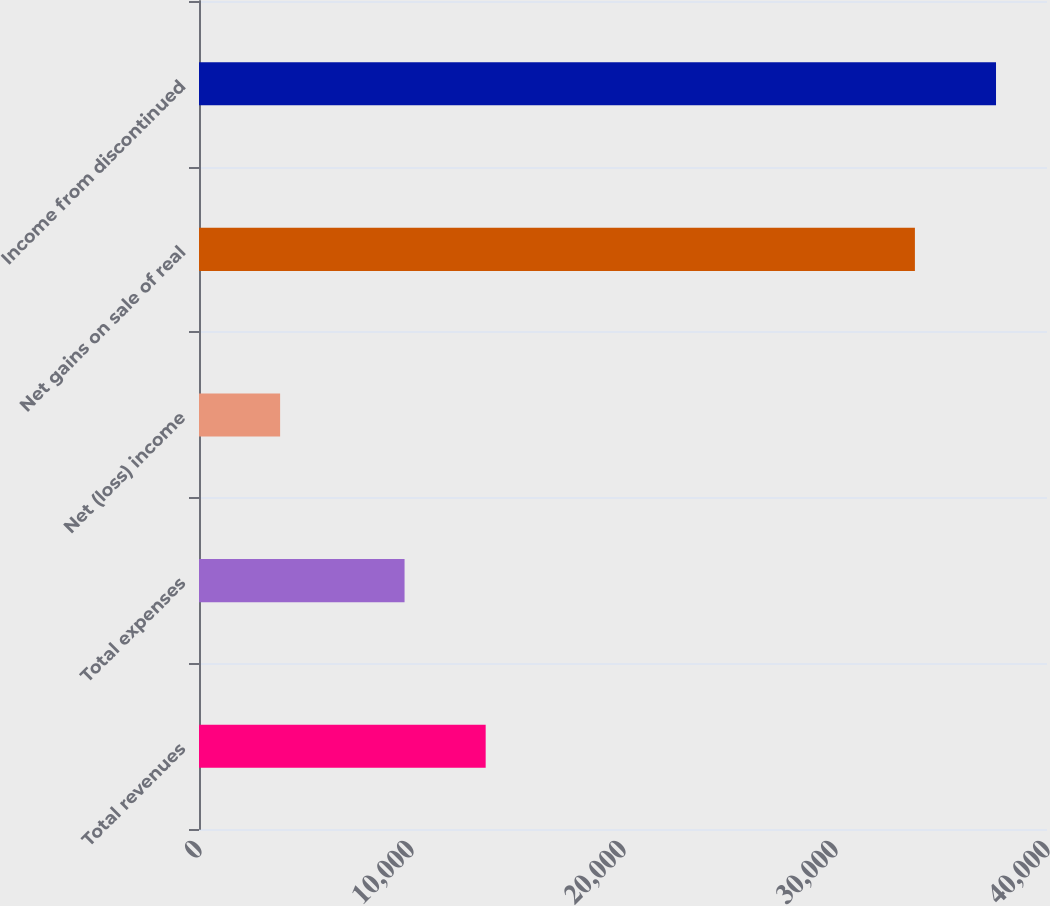<chart> <loc_0><loc_0><loc_500><loc_500><bar_chart><fcel>Total revenues<fcel>Total expenses<fcel>Net (loss) income<fcel>Net gains on sale of real<fcel>Income from discontinued<nl><fcel>13522<fcel>9696<fcel>3826<fcel>33769<fcel>37595<nl></chart> 